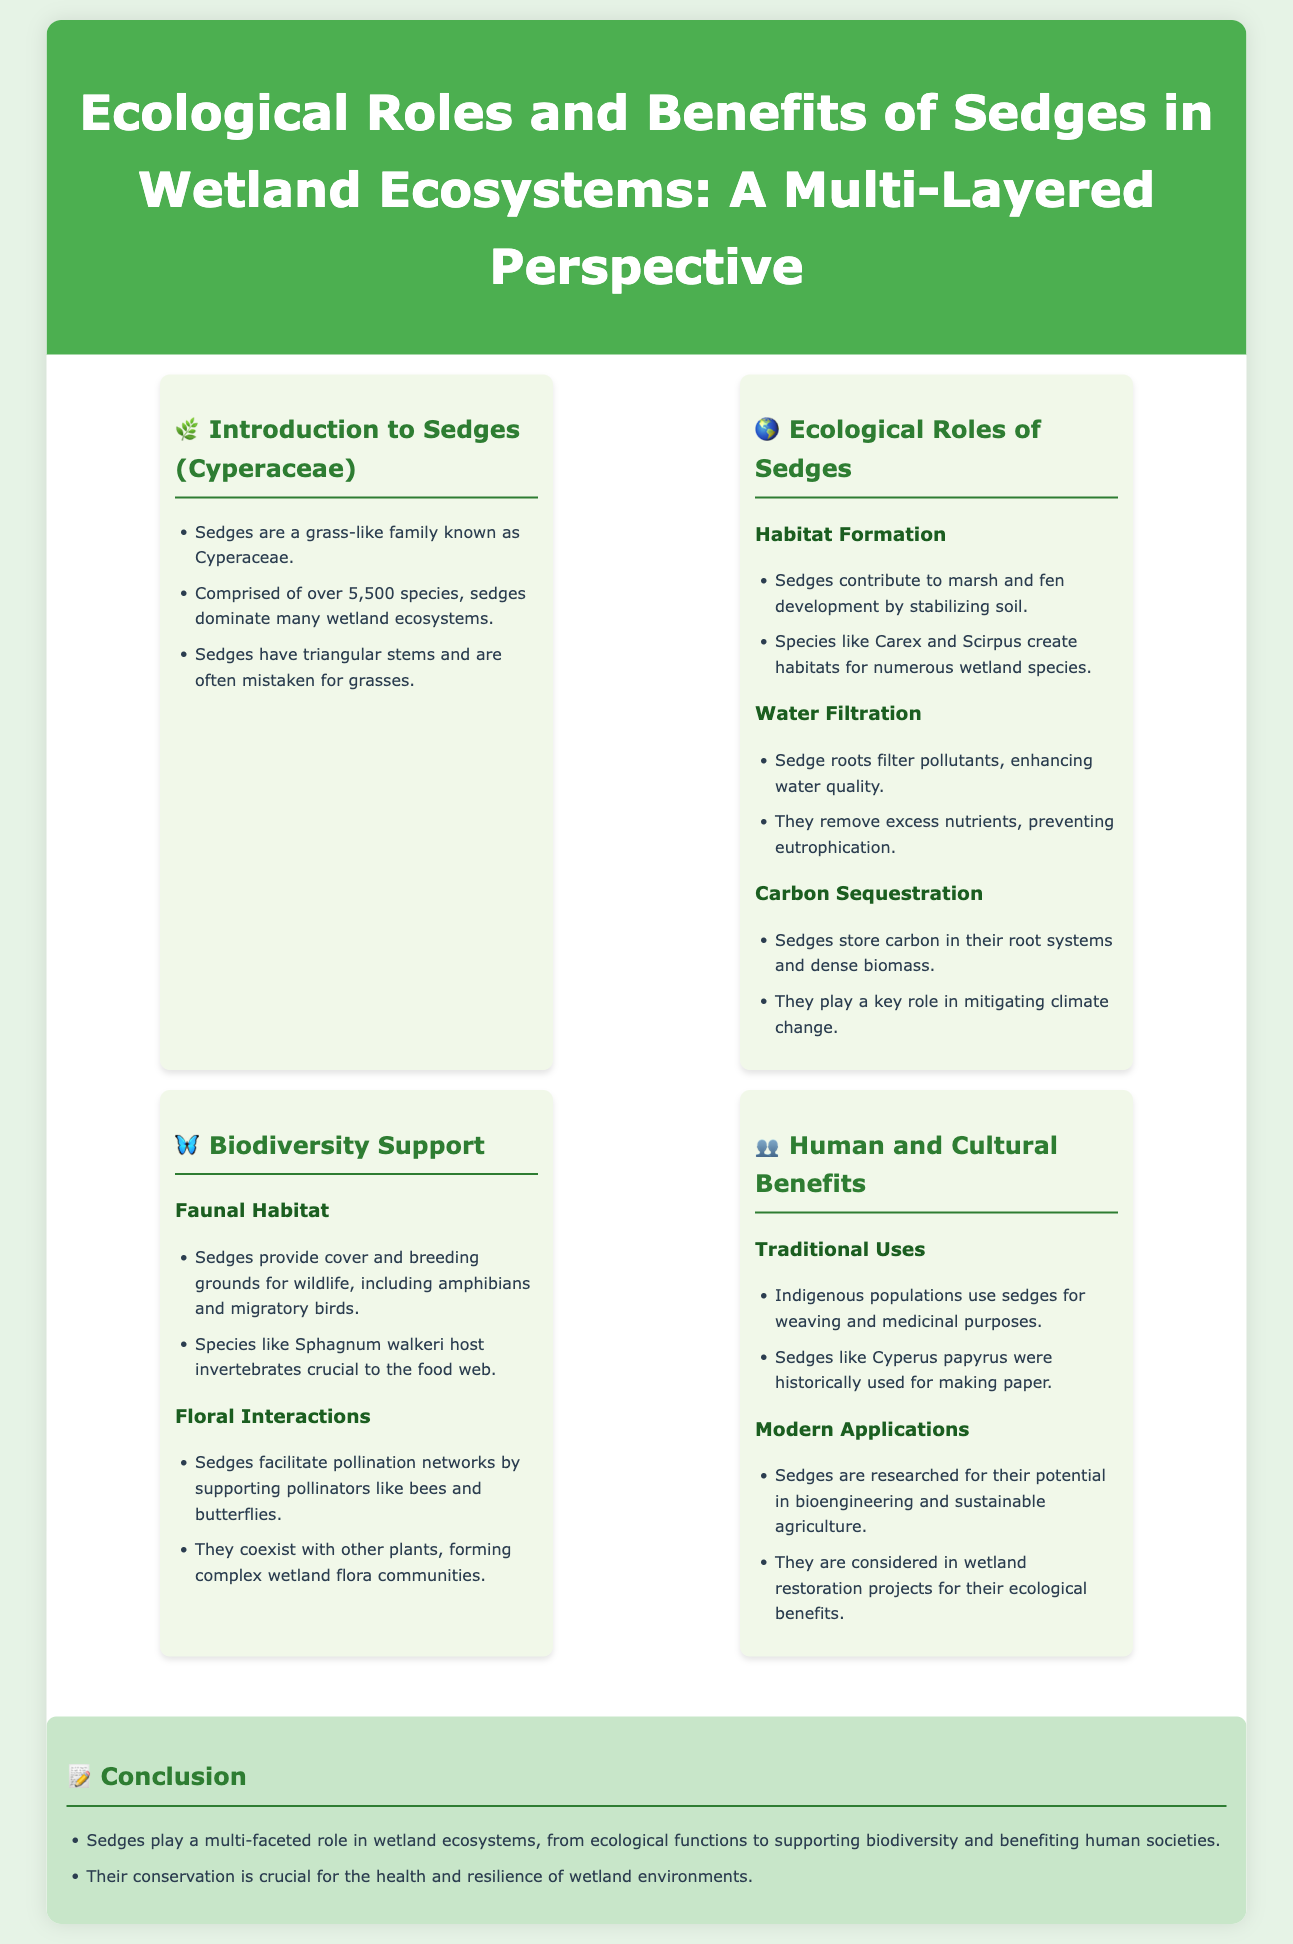what family do sedges belong to? Sedges are known as the Cyperaceae family, as stated in the introduction section.
Answer: Cyperaceae how many species of sedges are there? The document mentions that there are over 5,500 species of sedges.
Answer: over 5,500 what role do sedges play in pollination networks? The document states that sedges facilitate pollination networks by supporting pollinators like bees and butterflies.
Answer: support pollinators which species of sedges contribute to habitat formation? The text refers to Carex and Scirpus as species that contribute to habitat formation.
Answer: Carex and Scirpus what traditional purpose do Indigenous populations have for using sedges? The document mentions that Indigenous populations use sedges for weaving and medicinal purposes.
Answer: weaving and medicinal purposes what ecological function do sedges have related to climate change? The text highlights that sedges play a key role in mitigating climate change through carbon sequestration.
Answer: mitigating climate change which benefits of sedges are considered in modern applications? The document mentions that sedges are researched for their potential in bioengineering and sustainable agriculture.
Answer: bioengineering and sustainable agriculture what is the conclusion about the role of sedges in wetland ecosystems? The conclusion section provides a summary stating that sedges play a multi-faceted role in wetland ecosystems.
Answer: multi-faceted role 